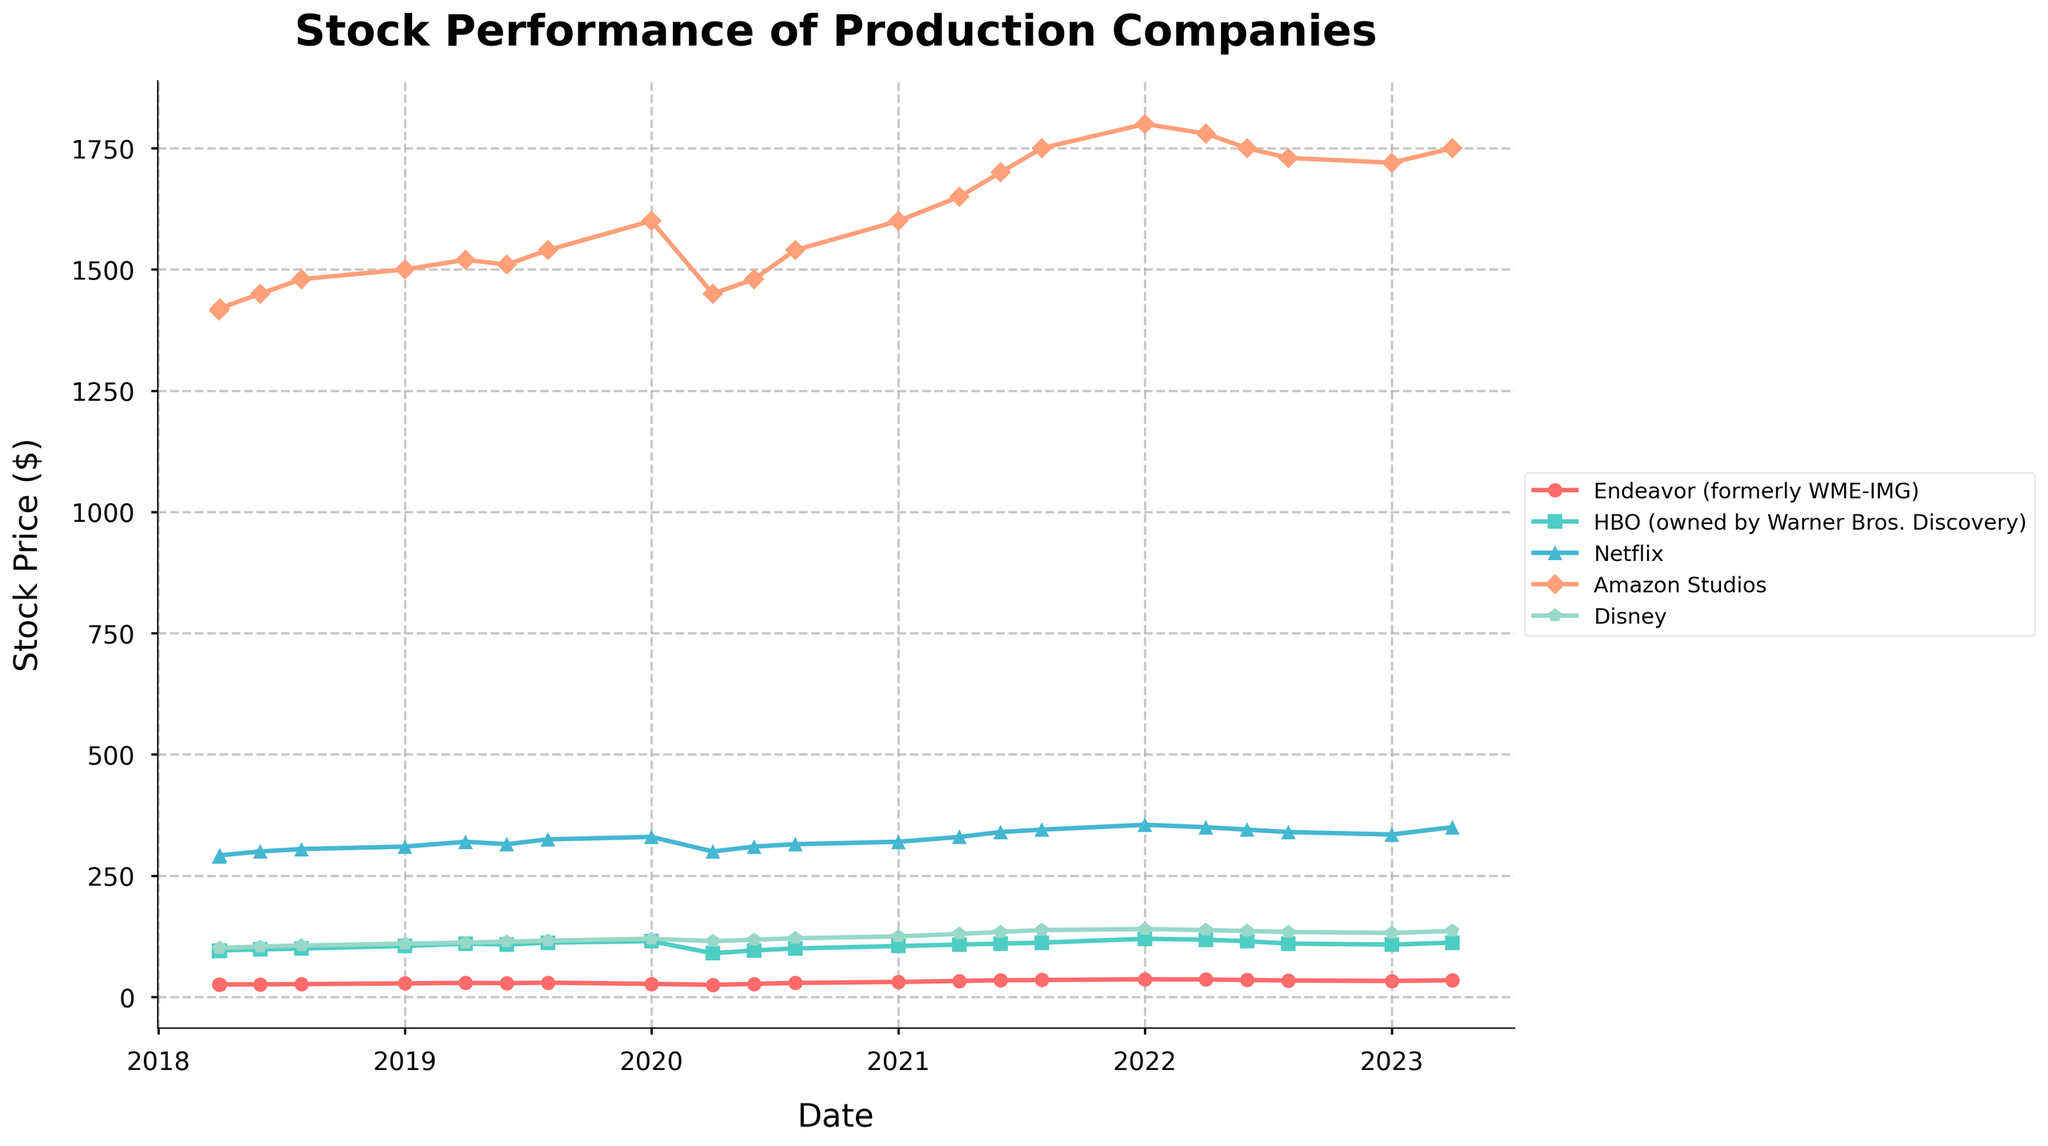Which company had the highest stock price on 2023-04-01? On 2023-04-01, compare the stock prices of all companies and identify which one has the highest value.
Answer: Netflix What is the time span covered by the data? Check the range of dates from the first entry to the last entry in the data. The first entry is 2018-04-01, and the last entry is 2023-04-01.
Answer: 5 years How did HBO (owned by Warner Bros. Discovery) stock perform during 2020? Review the data points for HBO in the year 2020 and observe the stock prices. Specifically, note the prices on 2020-01-01, 2020-04-01, 2020-06-01, and 2020-08-01.
Answer: The price decreased from 115 to 90 and then increased back to 100 Which company showed the highest growth in stock price from 2020-04-01 to 2021-01-01? Calculate the difference in stock prices between these two dates for each company. HBO: 105-90=15, Netflix: 320-300=20, Amazon: 1600-1450=150, Disney: 125-115=10, Endeavor: 31-25=6.
Answer: Amazon Studios What trend do you observe in Amazon Studios' stock performance over the entire period? Review the Amazon Studios' stock prices from the beginning to the end of the period. Note any rises, drops, or stability in the prices.
Answer: Overall increasing, with some fluctuations Between 2022-01-01 and 2023-04-01, which company's stock price decreased? Check the stock prices for each company on both dates and determine if there is a decrease. HBO: 108-120=-12, Netflix: 350-355=-5, Amazon: 1750-1800=-50, Disney: 136-140=-4. Endeavor's price increased.
Answer: HBO, Netflix, Amazon Studios, Disney Which company had a nearly constant stock price trend over the shown period? Examine the stock price plots and identify the company with minor variations in its stock price.
Answer: HBO What is the average stock price of Disney between 2018-04-01 and 2023-04-01? Calculate the mean of Disney's stock prices over all recorded dates. Sum the prices and divide by the total number of entries.
Answer: Average: 122.55 Were there any sharp declines in stock prices for Netflix in the period shown? If so, when? Look for sudden drops in the Netflix plot. The most noticeable drop is around 2020-04-01 from 330 to 300.
Answer: Yes, 2020-04-01 Compare the stock prices of Endeavor (formerly WME-IMG) and HBO on 2020-04-01. Which one was higher? Check the stock price for Endeavor and HBO on 2020-04-01.
Answer: HBO 